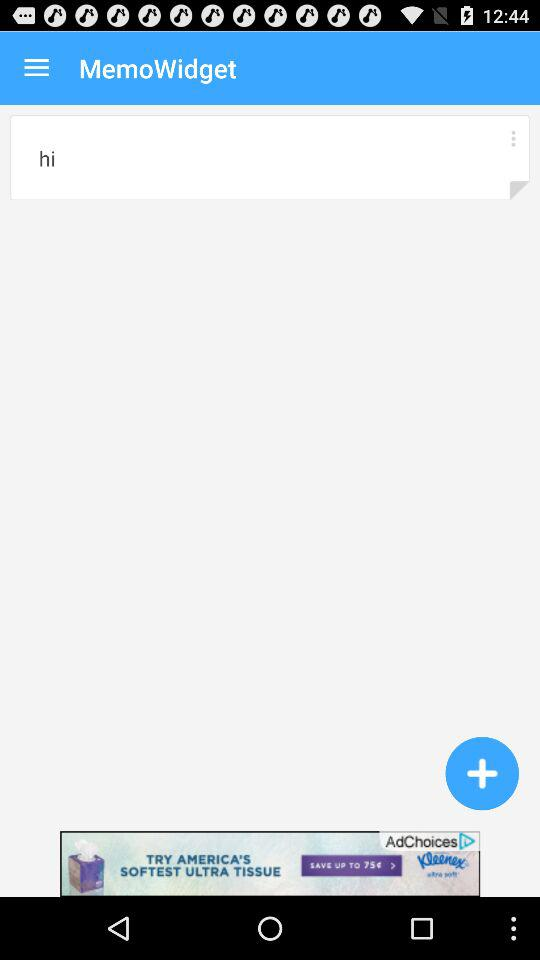What is the application name? The application name is "MemoWidget". 